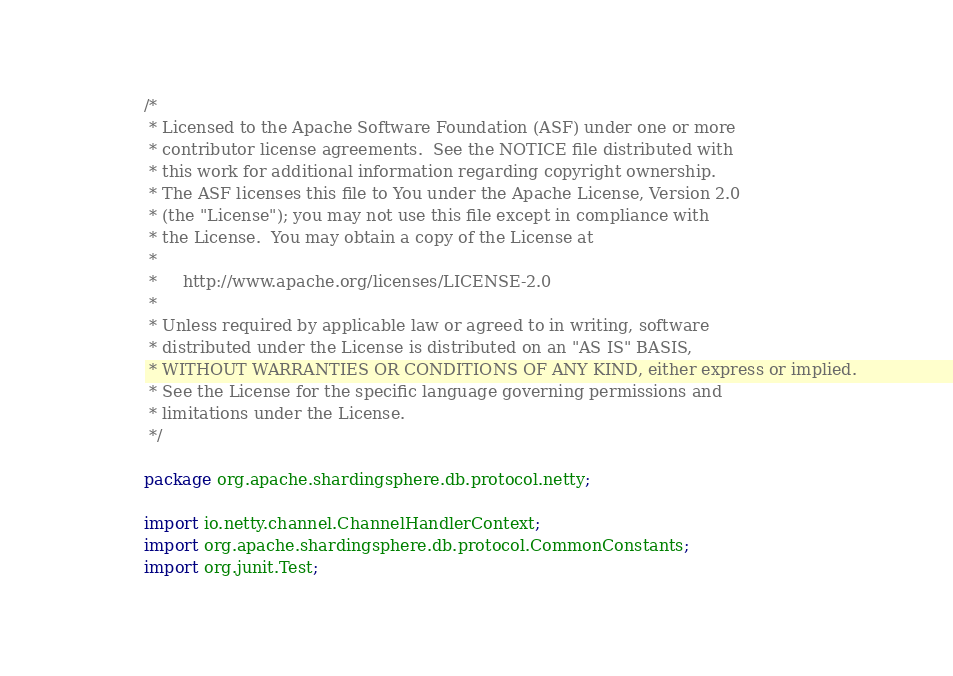<code> <loc_0><loc_0><loc_500><loc_500><_Java_>/*
 * Licensed to the Apache Software Foundation (ASF) under one or more
 * contributor license agreements.  See the NOTICE file distributed with
 * this work for additional information regarding copyright ownership.
 * The ASF licenses this file to You under the Apache License, Version 2.0
 * (the "License"); you may not use this file except in compliance with
 * the License.  You may obtain a copy of the License at
 *
 *     http://www.apache.org/licenses/LICENSE-2.0
 *
 * Unless required by applicable law or agreed to in writing, software
 * distributed under the License is distributed on an "AS IS" BASIS,
 * WITHOUT WARRANTIES OR CONDITIONS OF ANY KIND, either express or implied.
 * See the License for the specific language governing permissions and
 * limitations under the License.
 */

package org.apache.shardingsphere.db.protocol.netty;

import io.netty.channel.ChannelHandlerContext;
import org.apache.shardingsphere.db.protocol.CommonConstants;
import org.junit.Test;
</code> 